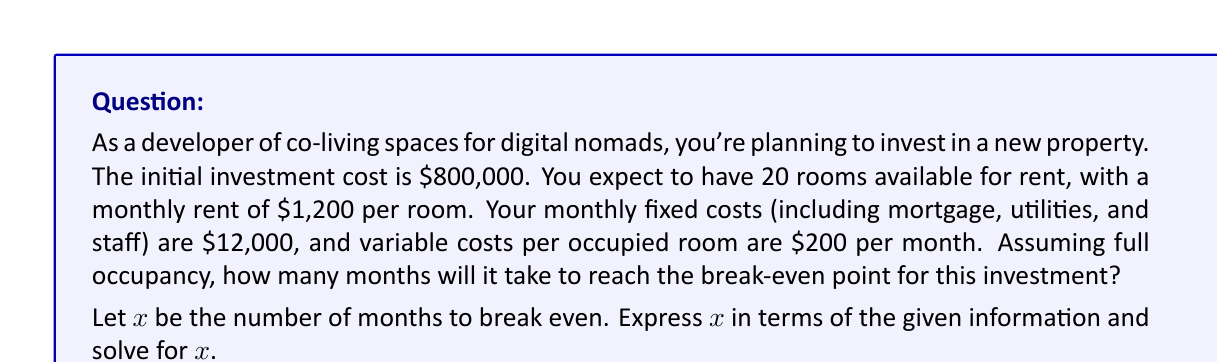Solve this math problem. To solve this problem, we need to set up an equation where the total revenue equals the total costs (including the initial investment). Let's break it down step-by-step:

1. Calculate monthly revenue:
   - Number of rooms: 20
   - Monthly rent per room: $1,200
   - Monthly revenue: $20 \times $1,200 = $24,000

2. Calculate monthly costs:
   - Fixed costs: $12,000
   - Variable costs: $20 \times $200 = $4,000
   - Total monthly costs: $12,000 + $4,000 = $16,000

3. Set up the break-even equation:
   $$(24,000x) = 800,000 + (16,000x)$$
   
   Where $x$ is the number of months, $24,000x$ is the total revenue over $x$ months, $800,000 is the initial investment, and $16,000x$ is the total costs over $x$ months.

4. Solve the equation:
   $$24,000x = 800,000 + 16,000x$$
   $$24,000x - 16,000x = 800,000$$
   $$8,000x = 800,000$$
   $$x = \frac{800,000}{8,000} = 100$$

Therefore, it will take 100 months to reach the break-even point.
Answer: 100 months 